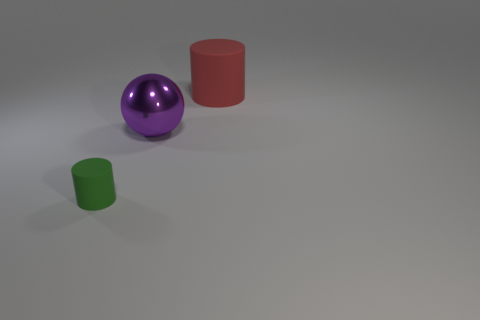Are there any other things that are the same shape as the metal thing?
Your answer should be very brief. No. There is a red matte thing that is the same shape as the small green matte thing; what is its size?
Offer a very short reply. Large. How many other big objects are made of the same material as the green object?
Offer a very short reply. 1. How many objects are cylinders in front of the purple shiny object or rubber cylinders behind the purple metallic ball?
Ensure brevity in your answer.  2. Are there fewer large purple things on the right side of the red cylinder than large things?
Provide a succinct answer. Yes. Are there any blue balls of the same size as the red rubber object?
Give a very brief answer. No. The large metallic ball has what color?
Your answer should be compact. Purple. Is the purple ball the same size as the green matte cylinder?
Make the answer very short. No. How many things are green rubber things or red matte cylinders?
Your answer should be very brief. 2. Are there an equal number of red rubber things behind the large red matte thing and matte cylinders?
Ensure brevity in your answer.  No. 